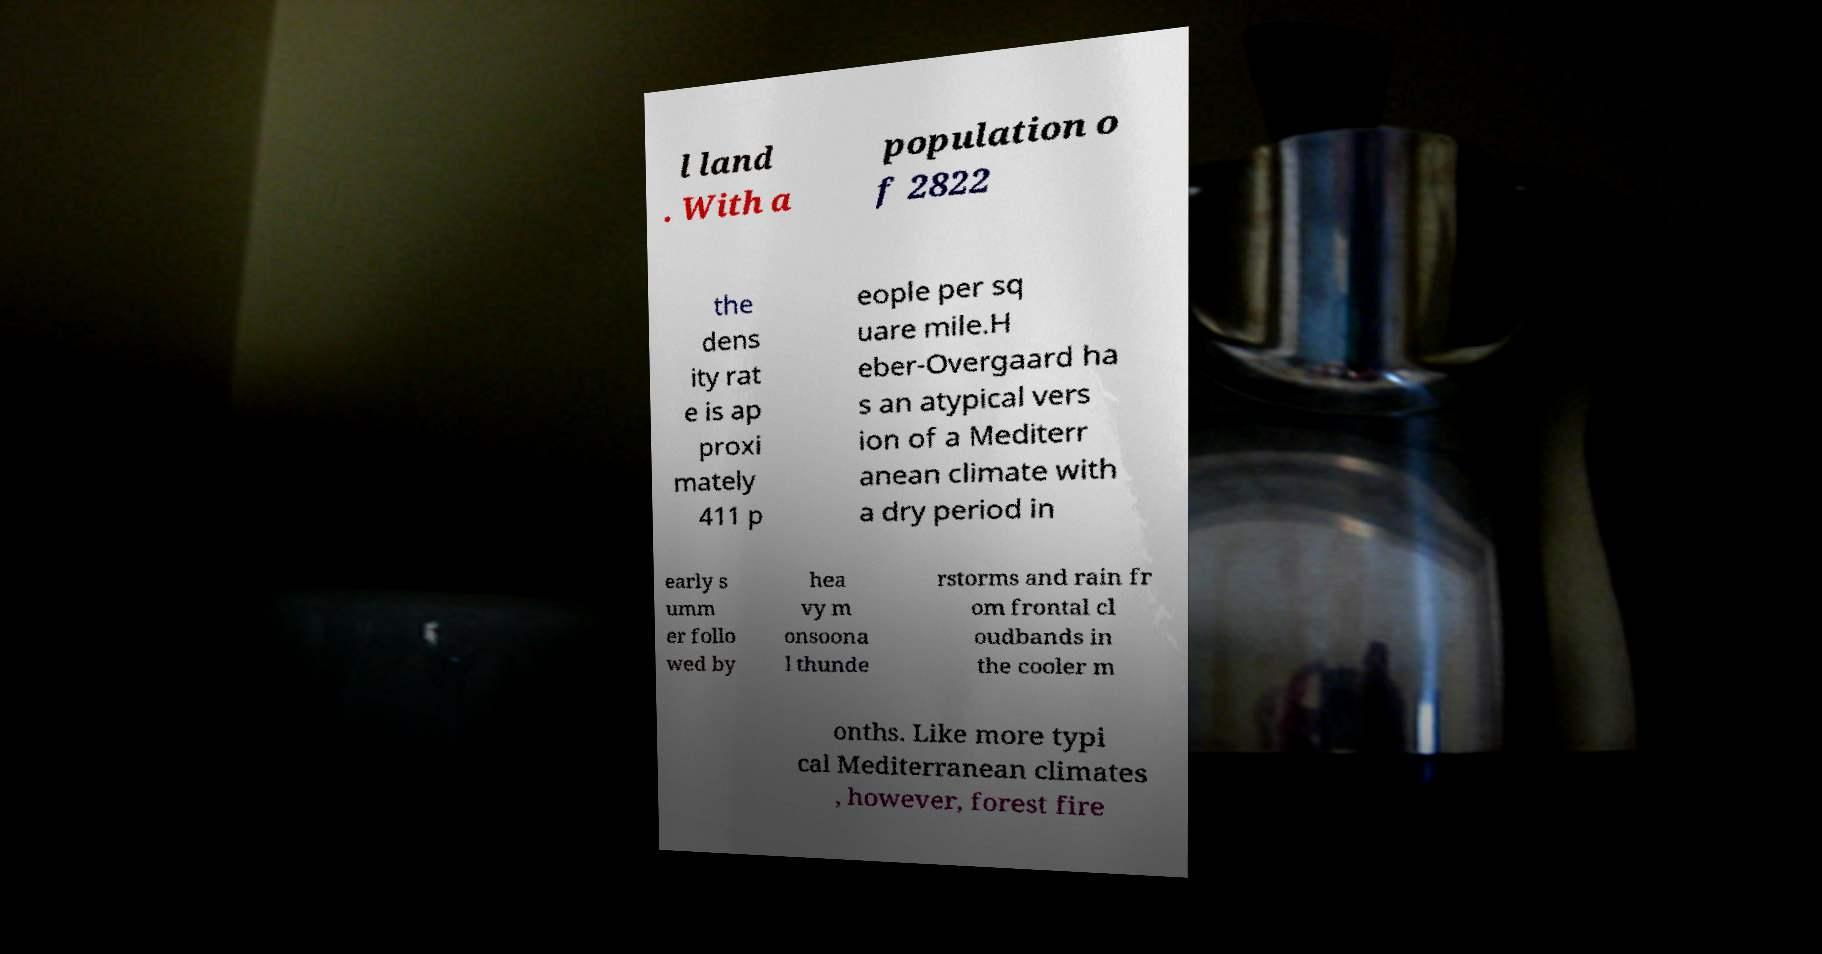Could you assist in decoding the text presented in this image and type it out clearly? l land . With a population o f 2822 the dens ity rat e is ap proxi mately 411 p eople per sq uare mile.H eber-Overgaard ha s an atypical vers ion of a Mediterr anean climate with a dry period in early s umm er follo wed by hea vy m onsoona l thunde rstorms and rain fr om frontal cl oudbands in the cooler m onths. Like more typi cal Mediterranean climates , however, forest fire 